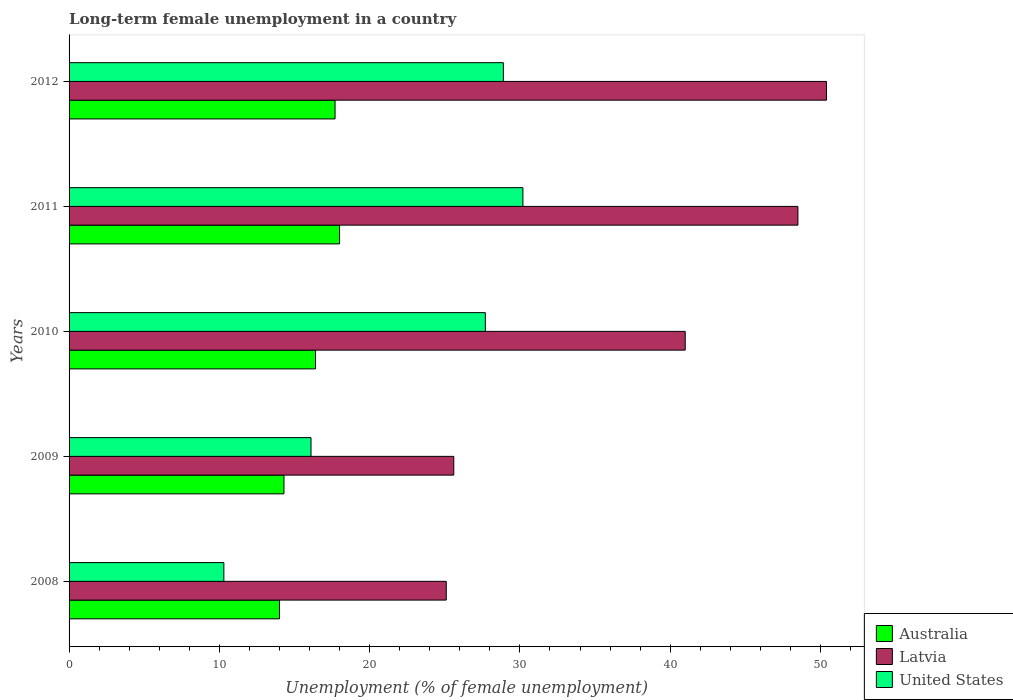How many different coloured bars are there?
Provide a short and direct response. 3. How many groups of bars are there?
Your response must be concise. 5. Are the number of bars on each tick of the Y-axis equal?
Your response must be concise. Yes. How many bars are there on the 4th tick from the top?
Your response must be concise. 3. How many bars are there on the 5th tick from the bottom?
Offer a terse response. 3. What is the label of the 3rd group of bars from the top?
Provide a short and direct response. 2010. Across all years, what is the maximum percentage of long-term unemployed female population in Australia?
Give a very brief answer. 18. In which year was the percentage of long-term unemployed female population in United States maximum?
Make the answer very short. 2011. What is the total percentage of long-term unemployed female population in Latvia in the graph?
Your answer should be compact. 190.6. What is the difference between the percentage of long-term unemployed female population in Latvia in 2008 and that in 2009?
Ensure brevity in your answer.  -0.5. What is the difference between the percentage of long-term unemployed female population in Latvia in 2010 and the percentage of long-term unemployed female population in United States in 2009?
Offer a terse response. 24.9. What is the average percentage of long-term unemployed female population in United States per year?
Give a very brief answer. 22.64. In the year 2010, what is the difference between the percentage of long-term unemployed female population in United States and percentage of long-term unemployed female population in Australia?
Offer a terse response. 11.3. What is the ratio of the percentage of long-term unemployed female population in United States in 2010 to that in 2011?
Your answer should be very brief. 0.92. Is the percentage of long-term unemployed female population in Australia in 2008 less than that in 2011?
Ensure brevity in your answer.  Yes. What is the difference between the highest and the second highest percentage of long-term unemployed female population in Latvia?
Provide a short and direct response. 1.9. What is the difference between the highest and the lowest percentage of long-term unemployed female population in United States?
Ensure brevity in your answer.  19.9. In how many years, is the percentage of long-term unemployed female population in United States greater than the average percentage of long-term unemployed female population in United States taken over all years?
Offer a terse response. 3. Is the sum of the percentage of long-term unemployed female population in Latvia in 2008 and 2011 greater than the maximum percentage of long-term unemployed female population in Australia across all years?
Offer a terse response. Yes. What does the 3rd bar from the top in 2009 represents?
Offer a very short reply. Australia. What does the 2nd bar from the bottom in 2010 represents?
Provide a succinct answer. Latvia. Are all the bars in the graph horizontal?
Ensure brevity in your answer.  Yes. What is the difference between two consecutive major ticks on the X-axis?
Your response must be concise. 10. Does the graph contain grids?
Your answer should be compact. No. Where does the legend appear in the graph?
Give a very brief answer. Bottom right. How many legend labels are there?
Keep it short and to the point. 3. What is the title of the graph?
Offer a very short reply. Long-term female unemployment in a country. Does "Bermuda" appear as one of the legend labels in the graph?
Your response must be concise. No. What is the label or title of the X-axis?
Provide a succinct answer. Unemployment (% of female unemployment). What is the Unemployment (% of female unemployment) in Latvia in 2008?
Your answer should be compact. 25.1. What is the Unemployment (% of female unemployment) of United States in 2008?
Ensure brevity in your answer.  10.3. What is the Unemployment (% of female unemployment) in Australia in 2009?
Make the answer very short. 14.3. What is the Unemployment (% of female unemployment) of Latvia in 2009?
Give a very brief answer. 25.6. What is the Unemployment (% of female unemployment) of United States in 2009?
Your response must be concise. 16.1. What is the Unemployment (% of female unemployment) in Australia in 2010?
Make the answer very short. 16.4. What is the Unemployment (% of female unemployment) in Latvia in 2010?
Ensure brevity in your answer.  41. What is the Unemployment (% of female unemployment) in United States in 2010?
Offer a terse response. 27.7. What is the Unemployment (% of female unemployment) in Latvia in 2011?
Provide a short and direct response. 48.5. What is the Unemployment (% of female unemployment) in United States in 2011?
Your answer should be compact. 30.2. What is the Unemployment (% of female unemployment) in Australia in 2012?
Your response must be concise. 17.7. What is the Unemployment (% of female unemployment) of Latvia in 2012?
Your answer should be compact. 50.4. What is the Unemployment (% of female unemployment) in United States in 2012?
Offer a terse response. 28.9. Across all years, what is the maximum Unemployment (% of female unemployment) of Australia?
Offer a very short reply. 18. Across all years, what is the maximum Unemployment (% of female unemployment) of Latvia?
Your response must be concise. 50.4. Across all years, what is the maximum Unemployment (% of female unemployment) in United States?
Make the answer very short. 30.2. Across all years, what is the minimum Unemployment (% of female unemployment) in Latvia?
Give a very brief answer. 25.1. Across all years, what is the minimum Unemployment (% of female unemployment) of United States?
Your response must be concise. 10.3. What is the total Unemployment (% of female unemployment) in Australia in the graph?
Make the answer very short. 80.4. What is the total Unemployment (% of female unemployment) in Latvia in the graph?
Provide a succinct answer. 190.6. What is the total Unemployment (% of female unemployment) in United States in the graph?
Keep it short and to the point. 113.2. What is the difference between the Unemployment (% of female unemployment) of Latvia in 2008 and that in 2009?
Give a very brief answer. -0.5. What is the difference between the Unemployment (% of female unemployment) in Latvia in 2008 and that in 2010?
Your response must be concise. -15.9. What is the difference between the Unemployment (% of female unemployment) of United States in 2008 and that in 2010?
Give a very brief answer. -17.4. What is the difference between the Unemployment (% of female unemployment) in Australia in 2008 and that in 2011?
Offer a very short reply. -4. What is the difference between the Unemployment (% of female unemployment) of Latvia in 2008 and that in 2011?
Offer a terse response. -23.4. What is the difference between the Unemployment (% of female unemployment) in United States in 2008 and that in 2011?
Provide a short and direct response. -19.9. What is the difference between the Unemployment (% of female unemployment) of Australia in 2008 and that in 2012?
Provide a succinct answer. -3.7. What is the difference between the Unemployment (% of female unemployment) in Latvia in 2008 and that in 2012?
Keep it short and to the point. -25.3. What is the difference between the Unemployment (% of female unemployment) of United States in 2008 and that in 2012?
Provide a succinct answer. -18.6. What is the difference between the Unemployment (% of female unemployment) in Australia in 2009 and that in 2010?
Provide a succinct answer. -2.1. What is the difference between the Unemployment (% of female unemployment) of Latvia in 2009 and that in 2010?
Offer a terse response. -15.4. What is the difference between the Unemployment (% of female unemployment) in Latvia in 2009 and that in 2011?
Offer a terse response. -22.9. What is the difference between the Unemployment (% of female unemployment) of United States in 2009 and that in 2011?
Offer a terse response. -14.1. What is the difference between the Unemployment (% of female unemployment) of Australia in 2009 and that in 2012?
Your answer should be very brief. -3.4. What is the difference between the Unemployment (% of female unemployment) in Latvia in 2009 and that in 2012?
Keep it short and to the point. -24.8. What is the difference between the Unemployment (% of female unemployment) in United States in 2009 and that in 2012?
Your answer should be very brief. -12.8. What is the difference between the Unemployment (% of female unemployment) of United States in 2010 and that in 2011?
Your response must be concise. -2.5. What is the difference between the Unemployment (% of female unemployment) of Latvia in 2010 and that in 2012?
Provide a short and direct response. -9.4. What is the difference between the Unemployment (% of female unemployment) of Australia in 2011 and that in 2012?
Offer a very short reply. 0.3. What is the difference between the Unemployment (% of female unemployment) in Australia in 2008 and the Unemployment (% of female unemployment) in Latvia in 2009?
Give a very brief answer. -11.6. What is the difference between the Unemployment (% of female unemployment) in Latvia in 2008 and the Unemployment (% of female unemployment) in United States in 2009?
Make the answer very short. 9. What is the difference between the Unemployment (% of female unemployment) of Australia in 2008 and the Unemployment (% of female unemployment) of Latvia in 2010?
Your answer should be compact. -27. What is the difference between the Unemployment (% of female unemployment) in Australia in 2008 and the Unemployment (% of female unemployment) in United States in 2010?
Your response must be concise. -13.7. What is the difference between the Unemployment (% of female unemployment) of Australia in 2008 and the Unemployment (% of female unemployment) of Latvia in 2011?
Offer a terse response. -34.5. What is the difference between the Unemployment (% of female unemployment) of Australia in 2008 and the Unemployment (% of female unemployment) of United States in 2011?
Make the answer very short. -16.2. What is the difference between the Unemployment (% of female unemployment) in Latvia in 2008 and the Unemployment (% of female unemployment) in United States in 2011?
Offer a very short reply. -5.1. What is the difference between the Unemployment (% of female unemployment) of Australia in 2008 and the Unemployment (% of female unemployment) of Latvia in 2012?
Make the answer very short. -36.4. What is the difference between the Unemployment (% of female unemployment) in Australia in 2008 and the Unemployment (% of female unemployment) in United States in 2012?
Provide a succinct answer. -14.9. What is the difference between the Unemployment (% of female unemployment) of Australia in 2009 and the Unemployment (% of female unemployment) of Latvia in 2010?
Provide a short and direct response. -26.7. What is the difference between the Unemployment (% of female unemployment) of Australia in 2009 and the Unemployment (% of female unemployment) of United States in 2010?
Offer a very short reply. -13.4. What is the difference between the Unemployment (% of female unemployment) of Australia in 2009 and the Unemployment (% of female unemployment) of Latvia in 2011?
Provide a succinct answer. -34.2. What is the difference between the Unemployment (% of female unemployment) in Australia in 2009 and the Unemployment (% of female unemployment) in United States in 2011?
Provide a succinct answer. -15.9. What is the difference between the Unemployment (% of female unemployment) of Australia in 2009 and the Unemployment (% of female unemployment) of Latvia in 2012?
Offer a terse response. -36.1. What is the difference between the Unemployment (% of female unemployment) of Australia in 2009 and the Unemployment (% of female unemployment) of United States in 2012?
Your answer should be compact. -14.6. What is the difference between the Unemployment (% of female unemployment) in Latvia in 2009 and the Unemployment (% of female unemployment) in United States in 2012?
Your answer should be very brief. -3.3. What is the difference between the Unemployment (% of female unemployment) in Australia in 2010 and the Unemployment (% of female unemployment) in Latvia in 2011?
Offer a terse response. -32.1. What is the difference between the Unemployment (% of female unemployment) in Latvia in 2010 and the Unemployment (% of female unemployment) in United States in 2011?
Provide a short and direct response. 10.8. What is the difference between the Unemployment (% of female unemployment) in Australia in 2010 and the Unemployment (% of female unemployment) in Latvia in 2012?
Offer a terse response. -34. What is the difference between the Unemployment (% of female unemployment) in Australia in 2010 and the Unemployment (% of female unemployment) in United States in 2012?
Give a very brief answer. -12.5. What is the difference between the Unemployment (% of female unemployment) in Latvia in 2010 and the Unemployment (% of female unemployment) in United States in 2012?
Your answer should be compact. 12.1. What is the difference between the Unemployment (% of female unemployment) in Australia in 2011 and the Unemployment (% of female unemployment) in Latvia in 2012?
Your response must be concise. -32.4. What is the difference between the Unemployment (% of female unemployment) in Australia in 2011 and the Unemployment (% of female unemployment) in United States in 2012?
Provide a short and direct response. -10.9. What is the difference between the Unemployment (% of female unemployment) in Latvia in 2011 and the Unemployment (% of female unemployment) in United States in 2012?
Make the answer very short. 19.6. What is the average Unemployment (% of female unemployment) in Australia per year?
Offer a very short reply. 16.08. What is the average Unemployment (% of female unemployment) of Latvia per year?
Your response must be concise. 38.12. What is the average Unemployment (% of female unemployment) in United States per year?
Offer a terse response. 22.64. In the year 2008, what is the difference between the Unemployment (% of female unemployment) in Australia and Unemployment (% of female unemployment) in Latvia?
Offer a very short reply. -11.1. In the year 2008, what is the difference between the Unemployment (% of female unemployment) of Australia and Unemployment (% of female unemployment) of United States?
Keep it short and to the point. 3.7. In the year 2009, what is the difference between the Unemployment (% of female unemployment) in Australia and Unemployment (% of female unemployment) in United States?
Make the answer very short. -1.8. In the year 2010, what is the difference between the Unemployment (% of female unemployment) of Australia and Unemployment (% of female unemployment) of Latvia?
Provide a succinct answer. -24.6. In the year 2010, what is the difference between the Unemployment (% of female unemployment) in Australia and Unemployment (% of female unemployment) in United States?
Ensure brevity in your answer.  -11.3. In the year 2011, what is the difference between the Unemployment (% of female unemployment) in Australia and Unemployment (% of female unemployment) in Latvia?
Provide a short and direct response. -30.5. In the year 2011, what is the difference between the Unemployment (% of female unemployment) of Australia and Unemployment (% of female unemployment) of United States?
Make the answer very short. -12.2. In the year 2011, what is the difference between the Unemployment (% of female unemployment) of Latvia and Unemployment (% of female unemployment) of United States?
Give a very brief answer. 18.3. In the year 2012, what is the difference between the Unemployment (% of female unemployment) in Australia and Unemployment (% of female unemployment) in Latvia?
Keep it short and to the point. -32.7. In the year 2012, what is the difference between the Unemployment (% of female unemployment) of Australia and Unemployment (% of female unemployment) of United States?
Provide a succinct answer. -11.2. In the year 2012, what is the difference between the Unemployment (% of female unemployment) of Latvia and Unemployment (% of female unemployment) of United States?
Keep it short and to the point. 21.5. What is the ratio of the Unemployment (% of female unemployment) of Latvia in 2008 to that in 2009?
Make the answer very short. 0.98. What is the ratio of the Unemployment (% of female unemployment) of United States in 2008 to that in 2009?
Make the answer very short. 0.64. What is the ratio of the Unemployment (% of female unemployment) in Australia in 2008 to that in 2010?
Your response must be concise. 0.85. What is the ratio of the Unemployment (% of female unemployment) in Latvia in 2008 to that in 2010?
Ensure brevity in your answer.  0.61. What is the ratio of the Unemployment (% of female unemployment) in United States in 2008 to that in 2010?
Keep it short and to the point. 0.37. What is the ratio of the Unemployment (% of female unemployment) of Australia in 2008 to that in 2011?
Offer a very short reply. 0.78. What is the ratio of the Unemployment (% of female unemployment) of Latvia in 2008 to that in 2011?
Your answer should be compact. 0.52. What is the ratio of the Unemployment (% of female unemployment) in United States in 2008 to that in 2011?
Offer a terse response. 0.34. What is the ratio of the Unemployment (% of female unemployment) in Australia in 2008 to that in 2012?
Ensure brevity in your answer.  0.79. What is the ratio of the Unemployment (% of female unemployment) in Latvia in 2008 to that in 2012?
Keep it short and to the point. 0.5. What is the ratio of the Unemployment (% of female unemployment) in United States in 2008 to that in 2012?
Ensure brevity in your answer.  0.36. What is the ratio of the Unemployment (% of female unemployment) of Australia in 2009 to that in 2010?
Offer a very short reply. 0.87. What is the ratio of the Unemployment (% of female unemployment) of Latvia in 2009 to that in 2010?
Your answer should be very brief. 0.62. What is the ratio of the Unemployment (% of female unemployment) in United States in 2009 to that in 2010?
Keep it short and to the point. 0.58. What is the ratio of the Unemployment (% of female unemployment) in Australia in 2009 to that in 2011?
Offer a terse response. 0.79. What is the ratio of the Unemployment (% of female unemployment) of Latvia in 2009 to that in 2011?
Provide a short and direct response. 0.53. What is the ratio of the Unemployment (% of female unemployment) in United States in 2009 to that in 2011?
Your answer should be very brief. 0.53. What is the ratio of the Unemployment (% of female unemployment) of Australia in 2009 to that in 2012?
Your answer should be very brief. 0.81. What is the ratio of the Unemployment (% of female unemployment) of Latvia in 2009 to that in 2012?
Make the answer very short. 0.51. What is the ratio of the Unemployment (% of female unemployment) in United States in 2009 to that in 2012?
Provide a succinct answer. 0.56. What is the ratio of the Unemployment (% of female unemployment) in Australia in 2010 to that in 2011?
Ensure brevity in your answer.  0.91. What is the ratio of the Unemployment (% of female unemployment) in Latvia in 2010 to that in 2011?
Give a very brief answer. 0.85. What is the ratio of the Unemployment (% of female unemployment) in United States in 2010 to that in 2011?
Give a very brief answer. 0.92. What is the ratio of the Unemployment (% of female unemployment) in Australia in 2010 to that in 2012?
Your response must be concise. 0.93. What is the ratio of the Unemployment (% of female unemployment) of Latvia in 2010 to that in 2012?
Make the answer very short. 0.81. What is the ratio of the Unemployment (% of female unemployment) in United States in 2010 to that in 2012?
Make the answer very short. 0.96. What is the ratio of the Unemployment (% of female unemployment) in Australia in 2011 to that in 2012?
Your answer should be compact. 1.02. What is the ratio of the Unemployment (% of female unemployment) in Latvia in 2011 to that in 2012?
Offer a terse response. 0.96. What is the ratio of the Unemployment (% of female unemployment) of United States in 2011 to that in 2012?
Your response must be concise. 1.04. What is the difference between the highest and the second highest Unemployment (% of female unemployment) in Australia?
Ensure brevity in your answer.  0.3. What is the difference between the highest and the second highest Unemployment (% of female unemployment) of United States?
Keep it short and to the point. 1.3. What is the difference between the highest and the lowest Unemployment (% of female unemployment) in Latvia?
Offer a terse response. 25.3. 